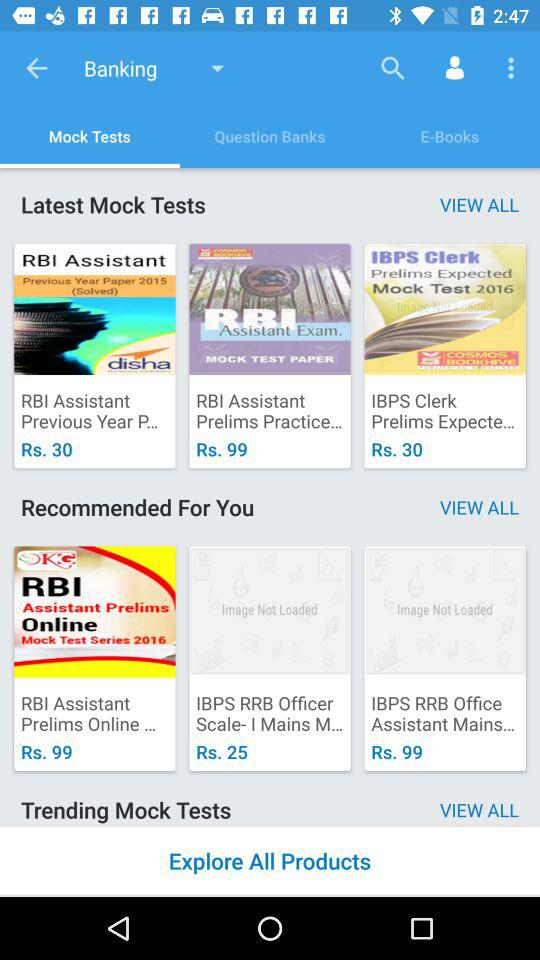What is the price of the "Prelims Practice"? The price of the "Prelims Practice" is Rs. 99. 